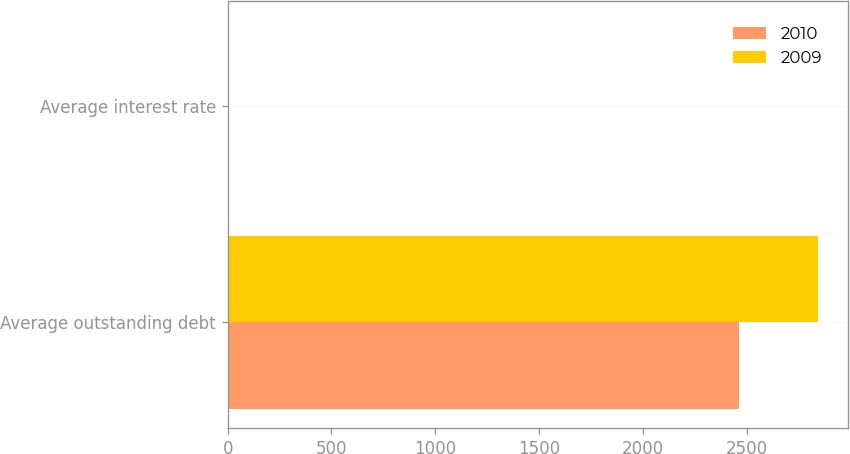<chart> <loc_0><loc_0><loc_500><loc_500><stacked_bar_chart><ecel><fcel>Average outstanding debt<fcel>Average interest rate<nl><fcel>2010<fcel>2461<fcel>4.8<nl><fcel>2009<fcel>2843.7<fcel>4.9<nl></chart> 